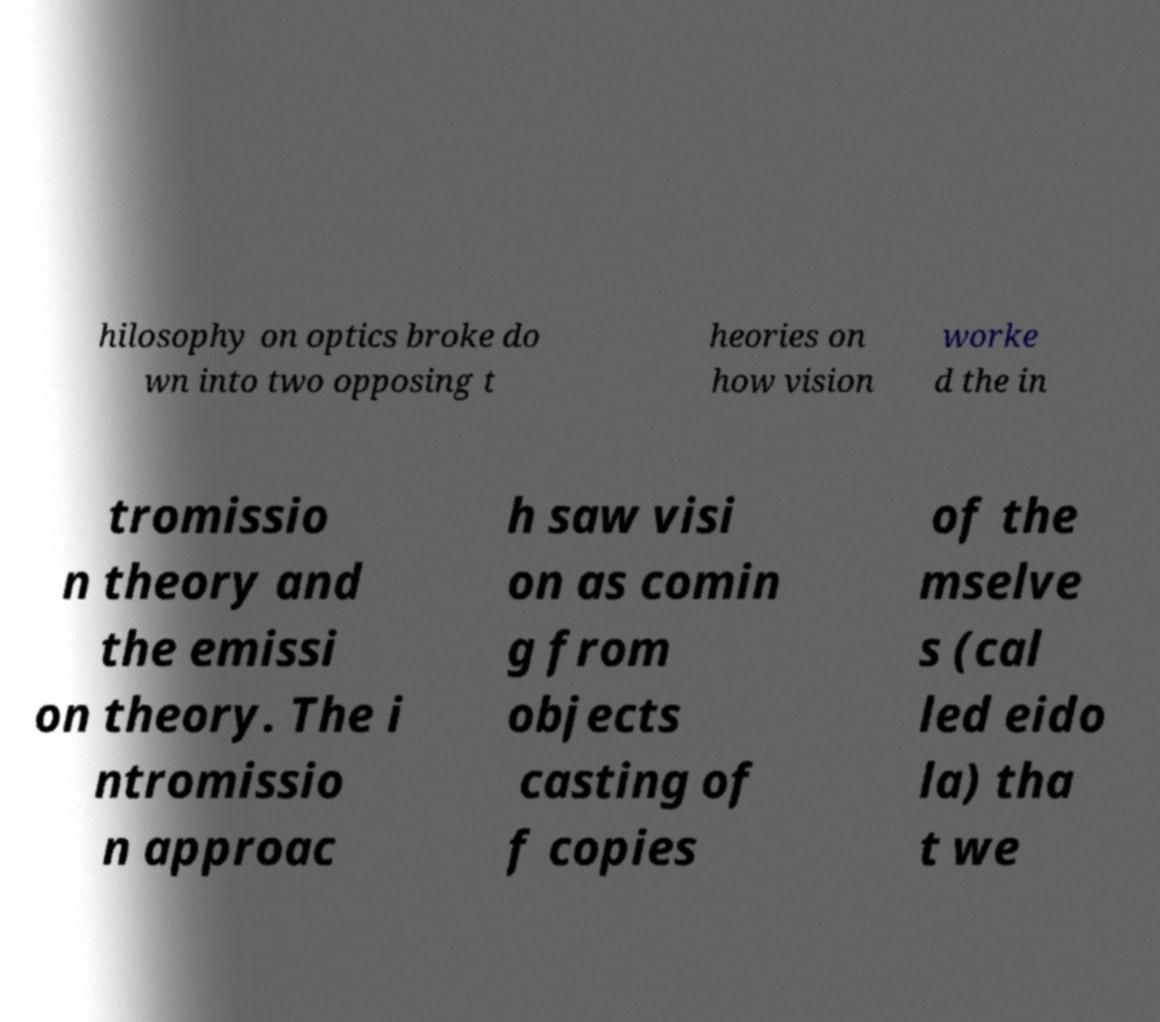Could you extract and type out the text from this image? hilosophy on optics broke do wn into two opposing t heories on how vision worke d the in tromissio n theory and the emissi on theory. The i ntromissio n approac h saw visi on as comin g from objects casting of f copies of the mselve s (cal led eido la) tha t we 